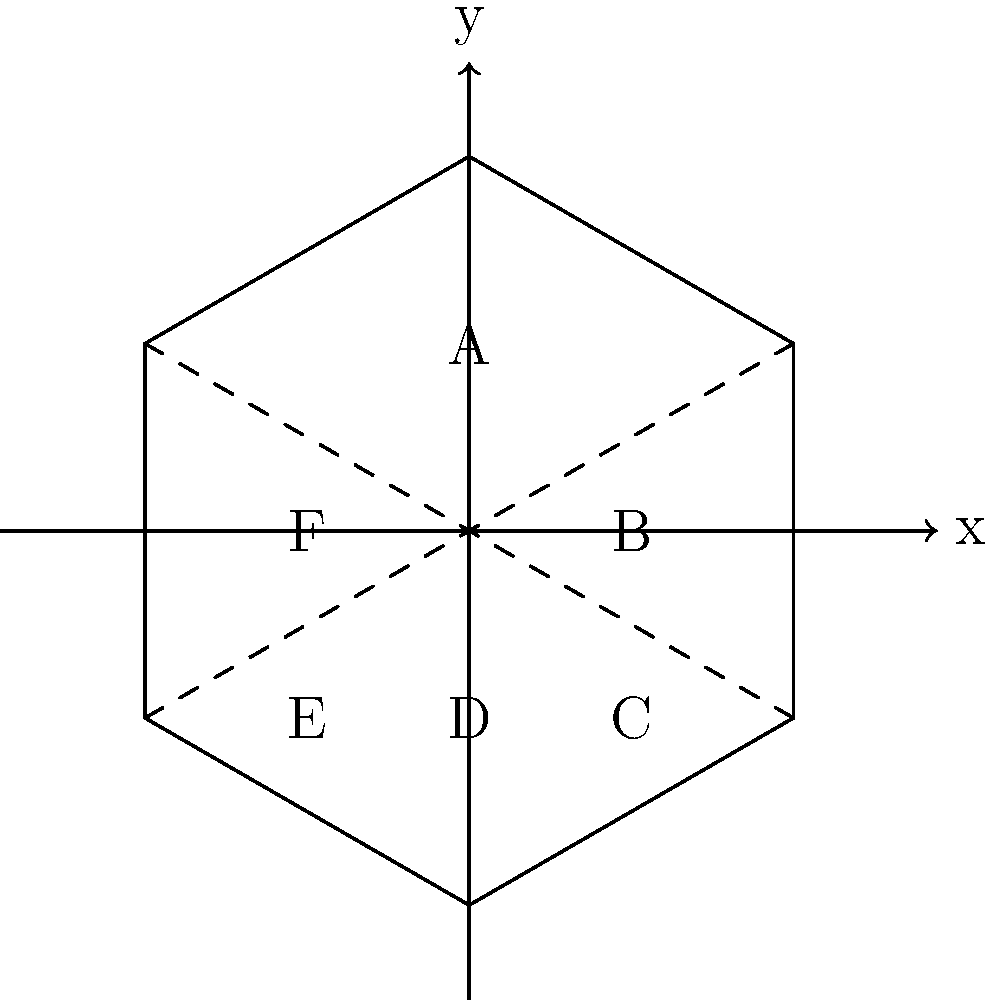In the context of distributed systems and data partitioning, consider the hexagonal coordinate system shown above. If we implement a consistent hashing algorithm that maps data to these partitions based on their hash values, which partition would likely experience the highest load if the hash function produces values uniformly distributed across the coordinate space? Explain your reasoning considering the geometric properties of the hexagon. To determine which partition would likely experience the highest load, we need to consider the following steps:

1. Understand the hexagonal coordinate system:
   - The hexagon is divided into six equal partitions (A, B, C, D, E, F).
   - The partitions are created by lines passing through the center of the hexagon.

2. Analyze the hash distribution:
   - The question states that the hash function produces values uniformly distributed across the coordinate space.
   - This means that each point in the coordinate space has an equal probability of being selected.

3. Consider the geometric properties:
   - In a regular hexagon, all sides are equal in length, and all interior angles are 120°.
   - However, the areas of the partitions are not equal when viewed in the Cartesian coordinate system.

4. Compare partition areas:
   - The partitions at the top and bottom (A and D) appear to have larger areas in the Cartesian plane.
   - The side partitions (B, C, E, F) have smaller areas when projected onto the Cartesian plane.

5. Relate area to data distribution:
   - With a uniform distribution of hash values across the coordinate space, partitions with larger areas will contain more data points.
   - Therefore, partitions A and D are likely to receive more data than the others.

6. Consider symmetry:
   - Due to the symmetry of the hexagon, partitions A and D have equal areas.

7. Conclusion:
   - Either partition A or D would likely experience the highest load, as they cover the largest areas in the Cartesian projection of the hexagonal coordinate system.
Answer: Partition A or D 